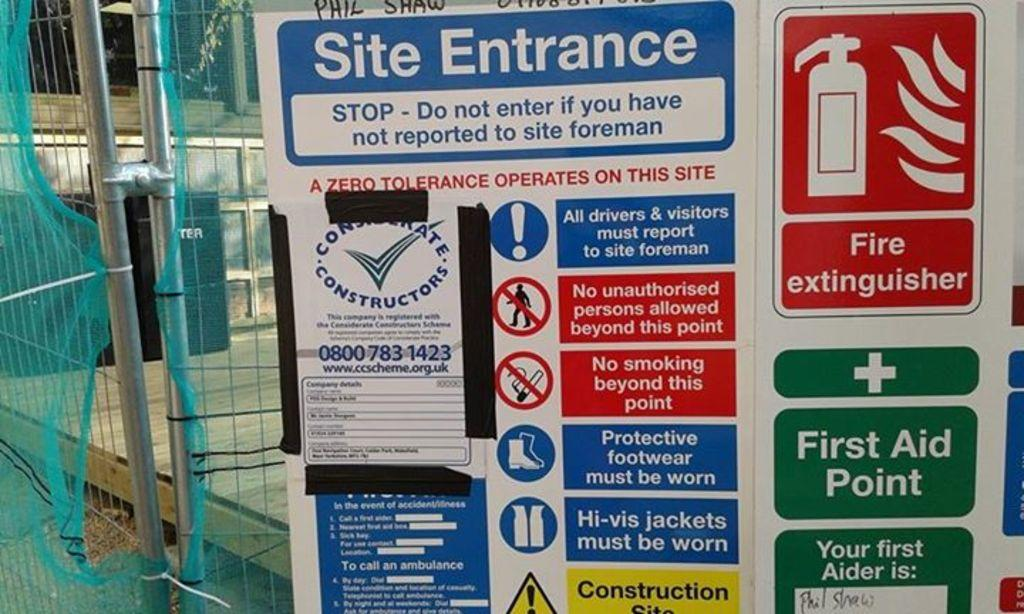<image>
Give a short and clear explanation of the subsequent image. a colorful board with a site entrance on it 